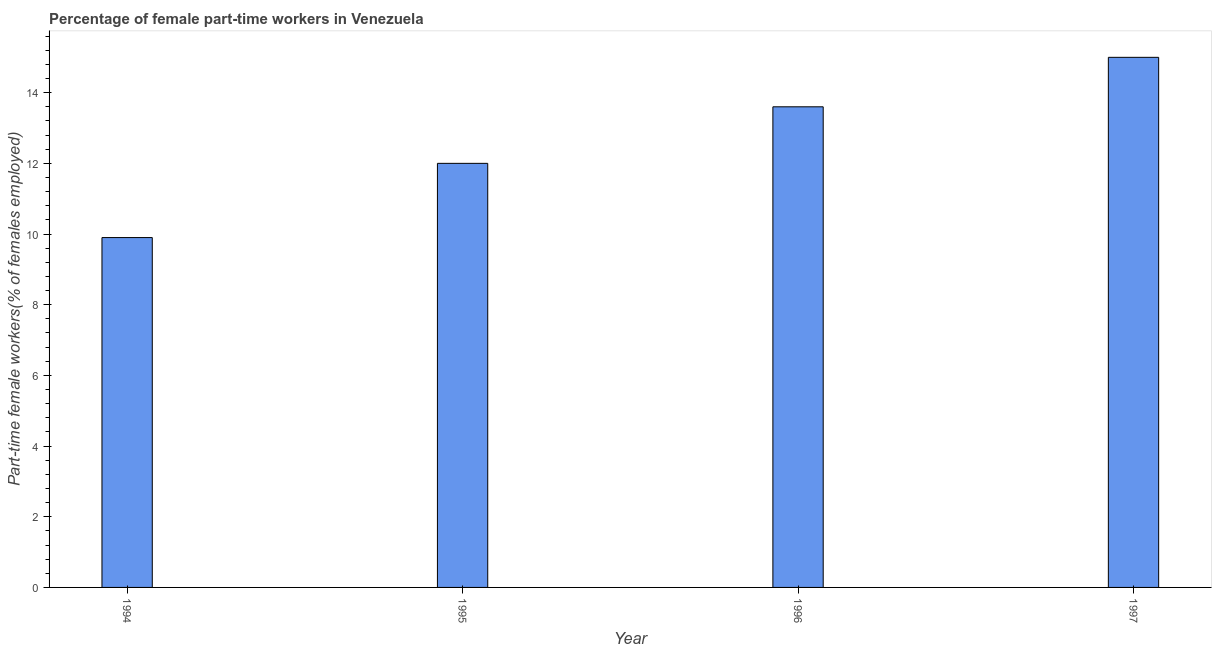Does the graph contain any zero values?
Make the answer very short. No. Does the graph contain grids?
Ensure brevity in your answer.  No. What is the title of the graph?
Provide a succinct answer. Percentage of female part-time workers in Venezuela. What is the label or title of the X-axis?
Your answer should be very brief. Year. What is the label or title of the Y-axis?
Give a very brief answer. Part-time female workers(% of females employed). Across all years, what is the maximum percentage of part-time female workers?
Provide a succinct answer. 15. Across all years, what is the minimum percentage of part-time female workers?
Provide a short and direct response. 9.9. In which year was the percentage of part-time female workers minimum?
Your response must be concise. 1994. What is the sum of the percentage of part-time female workers?
Provide a succinct answer. 50.5. What is the difference between the percentage of part-time female workers in 1995 and 1996?
Keep it short and to the point. -1.6. What is the average percentage of part-time female workers per year?
Give a very brief answer. 12.62. What is the median percentage of part-time female workers?
Your answer should be compact. 12.8. In how many years, is the percentage of part-time female workers greater than 15.2 %?
Your response must be concise. 0. Do a majority of the years between 1994 and 1997 (inclusive) have percentage of part-time female workers greater than 4 %?
Give a very brief answer. Yes. What is the ratio of the percentage of part-time female workers in 1994 to that in 1995?
Make the answer very short. 0.82. Is the sum of the percentage of part-time female workers in 1994 and 1997 greater than the maximum percentage of part-time female workers across all years?
Your response must be concise. Yes. What is the difference between the highest and the lowest percentage of part-time female workers?
Give a very brief answer. 5.1. In how many years, is the percentage of part-time female workers greater than the average percentage of part-time female workers taken over all years?
Your answer should be compact. 2. How many bars are there?
Your response must be concise. 4. How many years are there in the graph?
Offer a terse response. 4. Are the values on the major ticks of Y-axis written in scientific E-notation?
Provide a short and direct response. No. What is the Part-time female workers(% of females employed) of 1994?
Your answer should be very brief. 9.9. What is the Part-time female workers(% of females employed) of 1995?
Ensure brevity in your answer.  12. What is the Part-time female workers(% of females employed) of 1996?
Ensure brevity in your answer.  13.6. What is the Part-time female workers(% of females employed) of 1997?
Your response must be concise. 15. What is the ratio of the Part-time female workers(% of females employed) in 1994 to that in 1995?
Your response must be concise. 0.82. What is the ratio of the Part-time female workers(% of females employed) in 1994 to that in 1996?
Offer a very short reply. 0.73. What is the ratio of the Part-time female workers(% of females employed) in 1994 to that in 1997?
Your response must be concise. 0.66. What is the ratio of the Part-time female workers(% of females employed) in 1995 to that in 1996?
Offer a terse response. 0.88. What is the ratio of the Part-time female workers(% of females employed) in 1995 to that in 1997?
Provide a short and direct response. 0.8. What is the ratio of the Part-time female workers(% of females employed) in 1996 to that in 1997?
Your answer should be very brief. 0.91. 